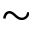Convert formula to latex. <formula><loc_0><loc_0><loc_500><loc_500>\sim</formula> 